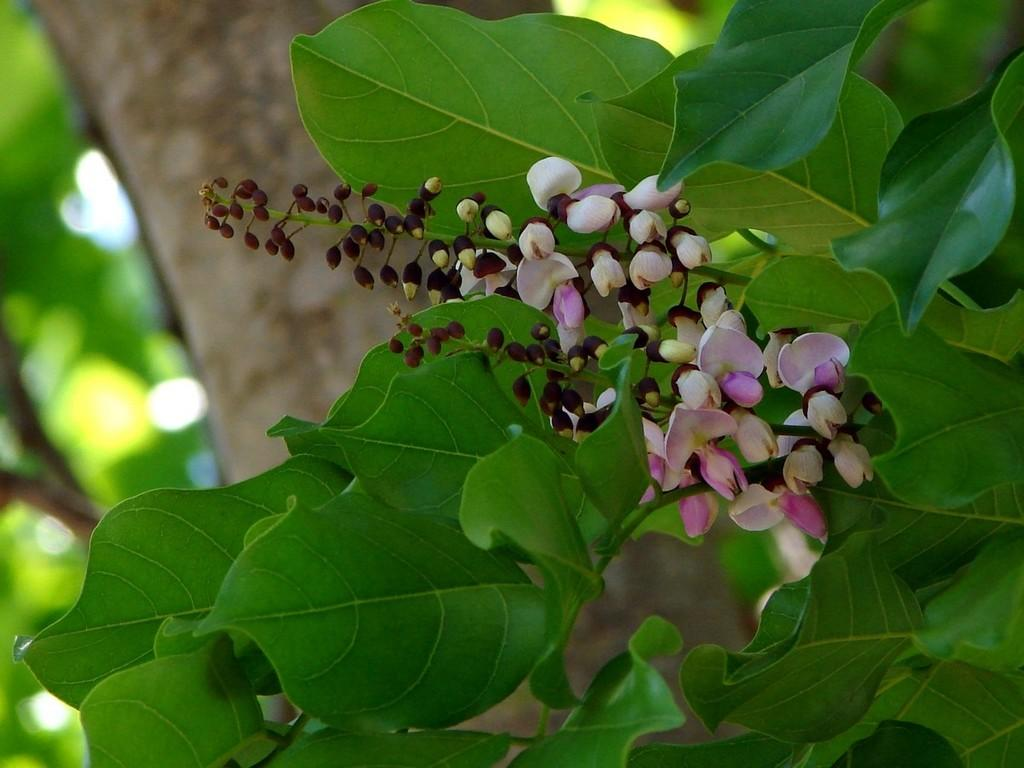What is present in the picture? There is a tree in the picture. Can you describe the tree in the picture? The tree has leaves and flowers. How low does the bucket hang from the tree in the picture? There is no bucket present in the image, so it cannot be determined how low it might hang from the tree. 